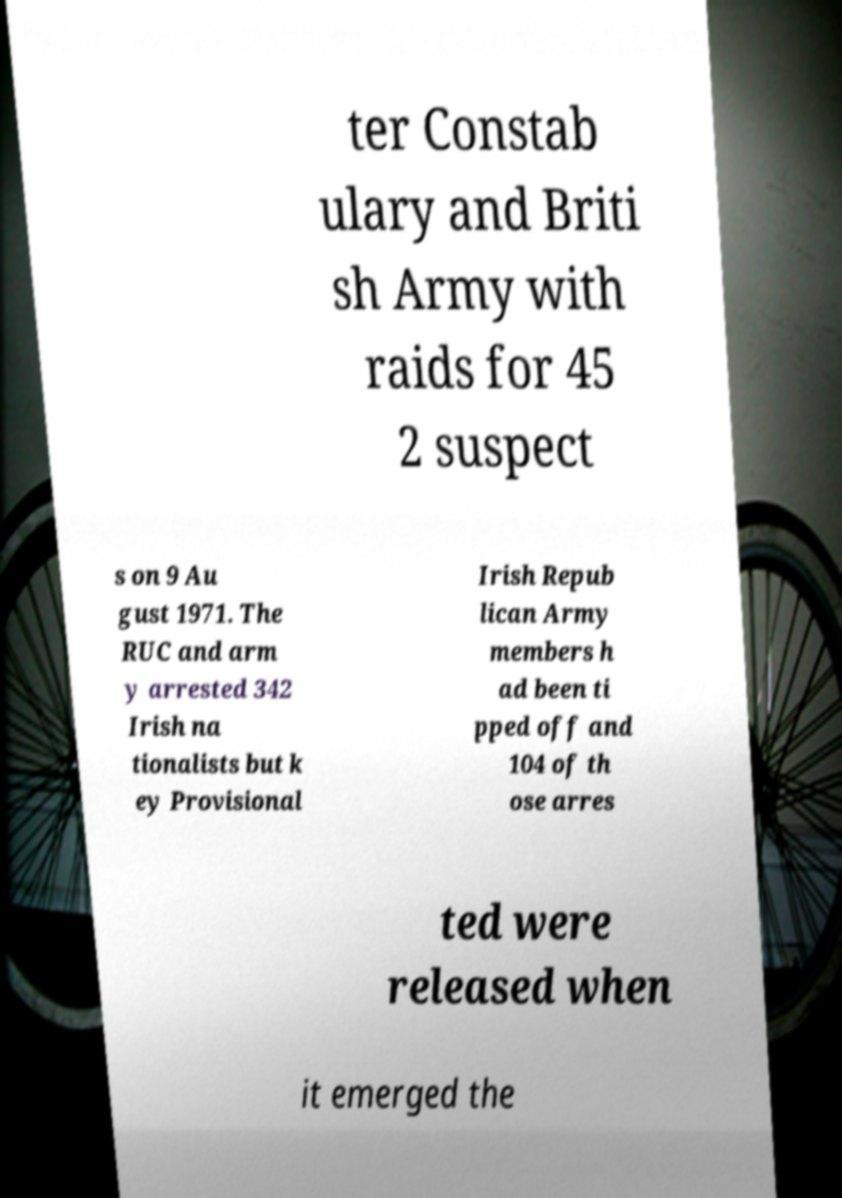For documentation purposes, I need the text within this image transcribed. Could you provide that? ter Constab ulary and Briti sh Army with raids for 45 2 suspect s on 9 Au gust 1971. The RUC and arm y arrested 342 Irish na tionalists but k ey Provisional Irish Repub lican Army members h ad been ti pped off and 104 of th ose arres ted were released when it emerged the 